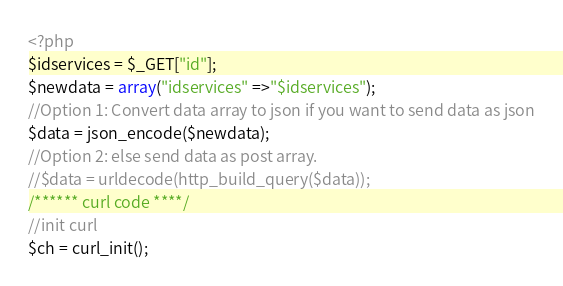Convert code to text. <code><loc_0><loc_0><loc_500><loc_500><_PHP_><?php
$idservices = $_GET["id"];
$newdata = array("idservices" =>"$idservices");
//Option 1: Convert data array to json if you want to send data as json
$data = json_encode($newdata);
//Option 2: else send data as post array.
//$data = urldecode(http_build_query($data));
/****** curl code ****/
//init curl
$ch = curl_init();</code> 